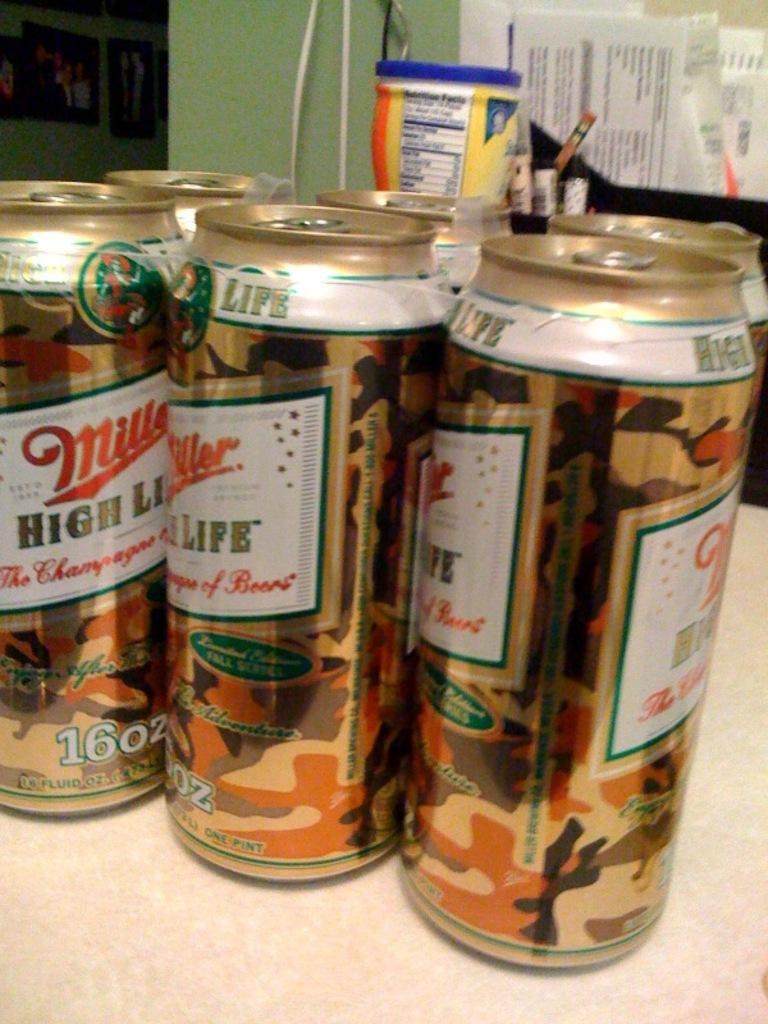<image>
Render a clear and concise summary of the photo. A six pack of Miller High Life 16 oz cans sits on a counter. 